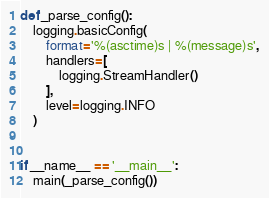<code> <loc_0><loc_0><loc_500><loc_500><_Python_>

def _parse_config():
    logging.basicConfig(
        format='%(asctime)s | %(message)s',
        handlers=[
            logging.StreamHandler()
        ],
        level=logging.INFO
    )


if __name__ == '__main__':
    main(_parse_config())
</code> 